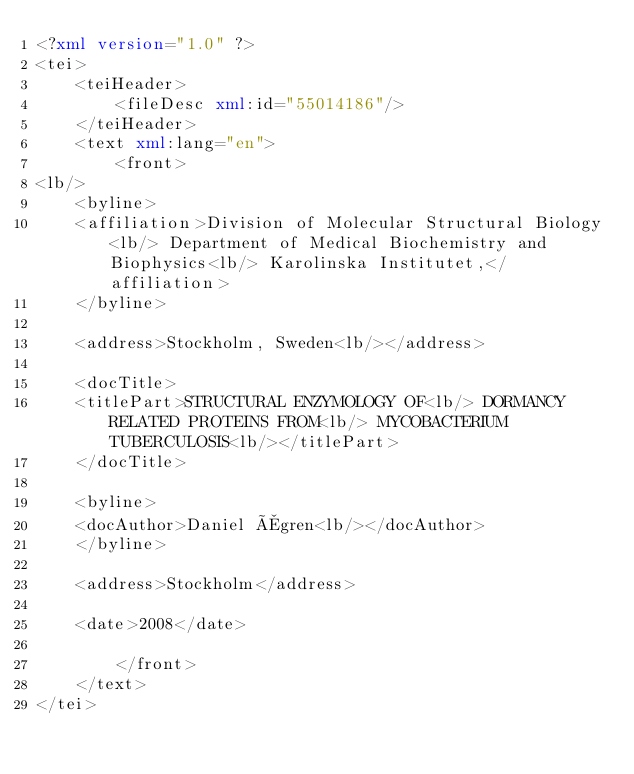<code> <loc_0><loc_0><loc_500><loc_500><_XML_><?xml version="1.0" ?>
<tei>
	<teiHeader>
		<fileDesc xml:id="55014186"/>
	</teiHeader>
	<text xml:lang="en">
		<front>
<lb/>
	<byline>
	<affiliation>Division of Molecular Structural Biology<lb/> Department of Medical Biochemistry and Biophysics<lb/> Karolinska Institutet,</affiliation>
	</byline> 

	<address>Stockholm, Sweden<lb/></address>

	<docTitle>
	<titlePart>STRUCTURAL ENZYMOLOGY OF<lb/> DORMANCY RELATED PROTEINS FROM<lb/> MYCOBACTERIUM TUBERCULOSIS<lb/></titlePart>
	</docTitle>

	<byline>
	<docAuthor>Daniel Ågren<lb/></docAuthor>
	</byline>

	<address>Stockholm</address>

	<date>2008</date>

		</front>
	</text>
</tei>
</code> 